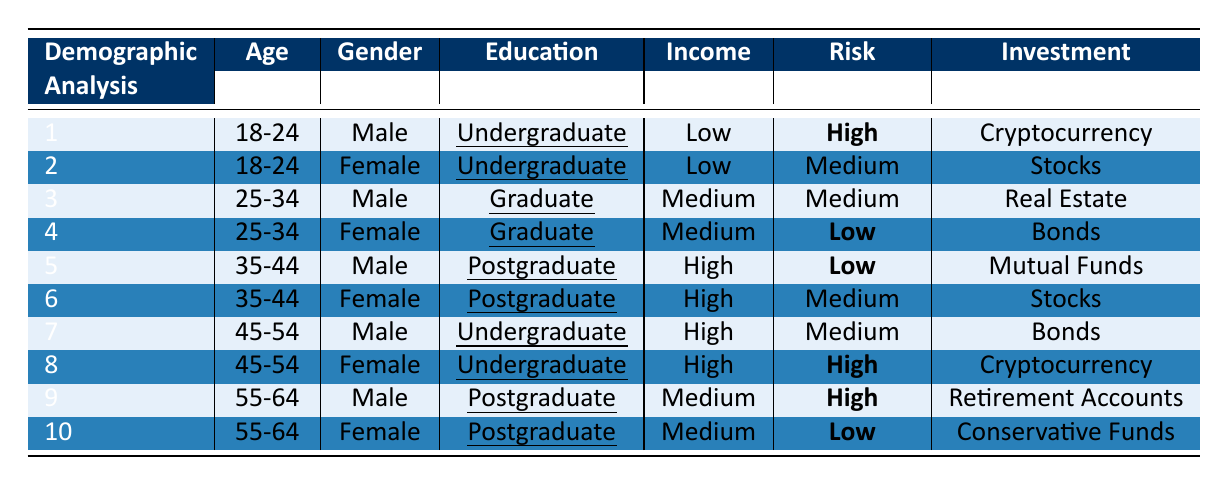What is the investment preference of the 55-64 age group male? In the table, under the "55-64" age group, for males, the "InvestmentPreference" is "Retirement Accounts."
Answer: Retirement Accounts How many individuals in the 45-54 age group have a high risk perception? In the table, only one female (row 8) in the 45-54 age group has a "RiskPerception" categorized as "High." Therefore, the count is one.
Answer: 1 What is the risk perception of undergraduate females in the 18-24 age group? Referring to the table, the only undergraduate female in the 18-24 age group (row 2) has a "RiskPerception" of "Medium."
Answer: Medium Are all individuals in the 35-44 age group females? The table shows that there is one male (row 5) and one female (row 6) in the 35-44 age group, so not all are females.
Answer: No What is the average risk perception level among the 25-34 age group? In the table: Males have "Medium," and females have "Low." Assigning numerical values (High=3, Medium=2, Low=1): (2 + 1) / 2 = 1.5. The average risk perception is "Low" since it's below 2.
Answer: Low Which gender in the 45-54 age group has a higher risk perception? The table shows that the male has "Medium" and the female has "High." Since "High" (female) is greater than "Medium" (male), the conclusion is drawn.
Answer: Female What percentage of males in the table prefer cryptocurrency as an investment? The total number of males is 5 (rows 1, 3, 5, 7, 9). Only 2 males (rows 1 and 8) prefer cryptocurrency. The percentage is (2 / 5) * 100 = 40%.
Answer: 40% Is the education level of the female in the 25-34 age group higher than that of the female in the 45-54 age group? Comparing the "EducationLevel," the female in the 25-34 age group has "Graduate," while the female in the 45-54 age group has "Undergraduate." Therefore, the education level of the former is higher.
Answer: Yes What is the investment preference for individuals aged 55-64 with high risk perception? The table shows that among the 55-64 age group, only the male (row 9) has a "RiskPerception" of "High," and the corresponding "InvestmentPreference" is "Retirement Accounts."
Answer: Retirement Accounts How many individuals in the table identify as having a low risk perception? From the table, the individuals with "Low" risk perception are from the 25-34 female, 35-44 male, and the 55-64 female. Counting these gives a total of three individuals.
Answer: 3 What is the only investment preference for the 18-24 age group with a high risk perception? The only individual in the 18-24 age group with a "High" risk perception is the male (row 1) whose "InvestmentPreference" is "Cryptocurrency."
Answer: Cryptocurrency 